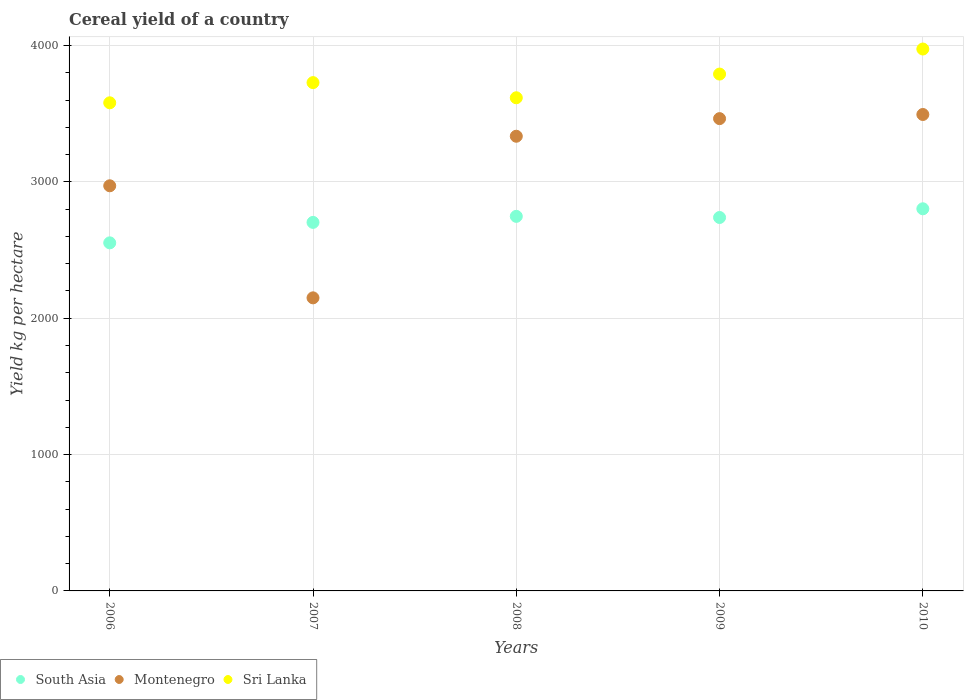Is the number of dotlines equal to the number of legend labels?
Your answer should be compact. Yes. What is the total cereal yield in South Asia in 2006?
Offer a very short reply. 2552.72. Across all years, what is the maximum total cereal yield in Sri Lanka?
Offer a very short reply. 3974.3. Across all years, what is the minimum total cereal yield in South Asia?
Ensure brevity in your answer.  2552.72. In which year was the total cereal yield in Montenegro minimum?
Your answer should be very brief. 2007. What is the total total cereal yield in Montenegro in the graph?
Keep it short and to the point. 1.54e+04. What is the difference between the total cereal yield in Montenegro in 2006 and that in 2009?
Provide a short and direct response. -492.53. What is the difference between the total cereal yield in Montenegro in 2009 and the total cereal yield in Sri Lanka in 2008?
Your answer should be compact. -152.98. What is the average total cereal yield in Montenegro per year?
Give a very brief answer. 3082.61. In the year 2008, what is the difference between the total cereal yield in Sri Lanka and total cereal yield in Montenegro?
Provide a short and direct response. 282.13. In how many years, is the total cereal yield in Sri Lanka greater than 3600 kg per hectare?
Offer a very short reply. 4. What is the ratio of the total cereal yield in Sri Lanka in 2006 to that in 2009?
Offer a terse response. 0.94. Is the difference between the total cereal yield in Sri Lanka in 2006 and 2009 greater than the difference between the total cereal yield in Montenegro in 2006 and 2009?
Your answer should be very brief. Yes. What is the difference between the highest and the second highest total cereal yield in Sri Lanka?
Give a very brief answer. 183.73. What is the difference between the highest and the lowest total cereal yield in South Asia?
Keep it short and to the point. 249.84. In how many years, is the total cereal yield in Montenegro greater than the average total cereal yield in Montenegro taken over all years?
Give a very brief answer. 3. Is it the case that in every year, the sum of the total cereal yield in Sri Lanka and total cereal yield in South Asia  is greater than the total cereal yield in Montenegro?
Offer a terse response. Yes. Is the total cereal yield in Montenegro strictly greater than the total cereal yield in Sri Lanka over the years?
Provide a short and direct response. No. Is the total cereal yield in South Asia strictly less than the total cereal yield in Montenegro over the years?
Give a very brief answer. No. How many years are there in the graph?
Make the answer very short. 5. Are the values on the major ticks of Y-axis written in scientific E-notation?
Offer a very short reply. No. Does the graph contain any zero values?
Ensure brevity in your answer.  No. Does the graph contain grids?
Offer a terse response. Yes. What is the title of the graph?
Ensure brevity in your answer.  Cereal yield of a country. Does "Tajikistan" appear as one of the legend labels in the graph?
Your answer should be very brief. No. What is the label or title of the X-axis?
Your response must be concise. Years. What is the label or title of the Y-axis?
Make the answer very short. Yield kg per hectare. What is the Yield kg per hectare in South Asia in 2006?
Offer a very short reply. 2552.72. What is the Yield kg per hectare of Montenegro in 2006?
Give a very brief answer. 2971.22. What is the Yield kg per hectare in Sri Lanka in 2006?
Your response must be concise. 3579.81. What is the Yield kg per hectare of South Asia in 2007?
Make the answer very short. 2702.79. What is the Yield kg per hectare in Montenegro in 2007?
Make the answer very short. 2149.37. What is the Yield kg per hectare of Sri Lanka in 2007?
Offer a terse response. 3727.89. What is the Yield kg per hectare of South Asia in 2008?
Ensure brevity in your answer.  2747.04. What is the Yield kg per hectare in Montenegro in 2008?
Your response must be concise. 3334.6. What is the Yield kg per hectare of Sri Lanka in 2008?
Provide a short and direct response. 3616.73. What is the Yield kg per hectare of South Asia in 2009?
Offer a terse response. 2738.72. What is the Yield kg per hectare in Montenegro in 2009?
Provide a succinct answer. 3463.75. What is the Yield kg per hectare of Sri Lanka in 2009?
Provide a short and direct response. 3790.57. What is the Yield kg per hectare of South Asia in 2010?
Your answer should be very brief. 2802.56. What is the Yield kg per hectare in Montenegro in 2010?
Provide a succinct answer. 3494.09. What is the Yield kg per hectare in Sri Lanka in 2010?
Provide a succinct answer. 3974.3. Across all years, what is the maximum Yield kg per hectare of South Asia?
Your response must be concise. 2802.56. Across all years, what is the maximum Yield kg per hectare of Montenegro?
Make the answer very short. 3494.09. Across all years, what is the maximum Yield kg per hectare of Sri Lanka?
Ensure brevity in your answer.  3974.3. Across all years, what is the minimum Yield kg per hectare in South Asia?
Make the answer very short. 2552.72. Across all years, what is the minimum Yield kg per hectare in Montenegro?
Your response must be concise. 2149.37. Across all years, what is the minimum Yield kg per hectare in Sri Lanka?
Keep it short and to the point. 3579.81. What is the total Yield kg per hectare in South Asia in the graph?
Your answer should be compact. 1.35e+04. What is the total Yield kg per hectare of Montenegro in the graph?
Ensure brevity in your answer.  1.54e+04. What is the total Yield kg per hectare of Sri Lanka in the graph?
Provide a succinct answer. 1.87e+04. What is the difference between the Yield kg per hectare in South Asia in 2006 and that in 2007?
Provide a short and direct response. -150.08. What is the difference between the Yield kg per hectare in Montenegro in 2006 and that in 2007?
Offer a terse response. 821.85. What is the difference between the Yield kg per hectare of Sri Lanka in 2006 and that in 2007?
Make the answer very short. -148.09. What is the difference between the Yield kg per hectare in South Asia in 2006 and that in 2008?
Offer a very short reply. -194.33. What is the difference between the Yield kg per hectare in Montenegro in 2006 and that in 2008?
Your response must be concise. -363.38. What is the difference between the Yield kg per hectare in Sri Lanka in 2006 and that in 2008?
Your answer should be compact. -36.92. What is the difference between the Yield kg per hectare of South Asia in 2006 and that in 2009?
Make the answer very short. -186.01. What is the difference between the Yield kg per hectare of Montenegro in 2006 and that in 2009?
Your answer should be compact. -492.52. What is the difference between the Yield kg per hectare of Sri Lanka in 2006 and that in 2009?
Give a very brief answer. -210.76. What is the difference between the Yield kg per hectare of South Asia in 2006 and that in 2010?
Offer a very short reply. -249.84. What is the difference between the Yield kg per hectare of Montenegro in 2006 and that in 2010?
Offer a terse response. -522.87. What is the difference between the Yield kg per hectare in Sri Lanka in 2006 and that in 2010?
Your answer should be very brief. -394.5. What is the difference between the Yield kg per hectare in South Asia in 2007 and that in 2008?
Keep it short and to the point. -44.25. What is the difference between the Yield kg per hectare of Montenegro in 2007 and that in 2008?
Keep it short and to the point. -1185.23. What is the difference between the Yield kg per hectare in Sri Lanka in 2007 and that in 2008?
Ensure brevity in your answer.  111.16. What is the difference between the Yield kg per hectare of South Asia in 2007 and that in 2009?
Keep it short and to the point. -35.93. What is the difference between the Yield kg per hectare of Montenegro in 2007 and that in 2009?
Ensure brevity in your answer.  -1314.38. What is the difference between the Yield kg per hectare of Sri Lanka in 2007 and that in 2009?
Offer a very short reply. -62.68. What is the difference between the Yield kg per hectare in South Asia in 2007 and that in 2010?
Provide a succinct answer. -99.76. What is the difference between the Yield kg per hectare in Montenegro in 2007 and that in 2010?
Your answer should be compact. -1344.72. What is the difference between the Yield kg per hectare of Sri Lanka in 2007 and that in 2010?
Offer a terse response. -246.41. What is the difference between the Yield kg per hectare in South Asia in 2008 and that in 2009?
Provide a short and direct response. 8.32. What is the difference between the Yield kg per hectare of Montenegro in 2008 and that in 2009?
Provide a short and direct response. -129.15. What is the difference between the Yield kg per hectare of Sri Lanka in 2008 and that in 2009?
Ensure brevity in your answer.  -173.84. What is the difference between the Yield kg per hectare in South Asia in 2008 and that in 2010?
Offer a very short reply. -55.52. What is the difference between the Yield kg per hectare of Montenegro in 2008 and that in 2010?
Make the answer very short. -159.49. What is the difference between the Yield kg per hectare of Sri Lanka in 2008 and that in 2010?
Offer a terse response. -357.57. What is the difference between the Yield kg per hectare of South Asia in 2009 and that in 2010?
Offer a very short reply. -63.83. What is the difference between the Yield kg per hectare in Montenegro in 2009 and that in 2010?
Offer a terse response. -30.34. What is the difference between the Yield kg per hectare of Sri Lanka in 2009 and that in 2010?
Ensure brevity in your answer.  -183.73. What is the difference between the Yield kg per hectare in South Asia in 2006 and the Yield kg per hectare in Montenegro in 2007?
Make the answer very short. 403.35. What is the difference between the Yield kg per hectare of South Asia in 2006 and the Yield kg per hectare of Sri Lanka in 2007?
Offer a very short reply. -1175.18. What is the difference between the Yield kg per hectare in Montenegro in 2006 and the Yield kg per hectare in Sri Lanka in 2007?
Your answer should be compact. -756.67. What is the difference between the Yield kg per hectare of South Asia in 2006 and the Yield kg per hectare of Montenegro in 2008?
Provide a short and direct response. -781.88. What is the difference between the Yield kg per hectare of South Asia in 2006 and the Yield kg per hectare of Sri Lanka in 2008?
Provide a succinct answer. -1064.01. What is the difference between the Yield kg per hectare in Montenegro in 2006 and the Yield kg per hectare in Sri Lanka in 2008?
Your response must be concise. -645.51. What is the difference between the Yield kg per hectare in South Asia in 2006 and the Yield kg per hectare in Montenegro in 2009?
Provide a short and direct response. -911.03. What is the difference between the Yield kg per hectare in South Asia in 2006 and the Yield kg per hectare in Sri Lanka in 2009?
Your response must be concise. -1237.86. What is the difference between the Yield kg per hectare in Montenegro in 2006 and the Yield kg per hectare in Sri Lanka in 2009?
Give a very brief answer. -819.35. What is the difference between the Yield kg per hectare of South Asia in 2006 and the Yield kg per hectare of Montenegro in 2010?
Provide a short and direct response. -941.37. What is the difference between the Yield kg per hectare in South Asia in 2006 and the Yield kg per hectare in Sri Lanka in 2010?
Offer a very short reply. -1421.59. What is the difference between the Yield kg per hectare of Montenegro in 2006 and the Yield kg per hectare of Sri Lanka in 2010?
Keep it short and to the point. -1003.08. What is the difference between the Yield kg per hectare in South Asia in 2007 and the Yield kg per hectare in Montenegro in 2008?
Your answer should be very brief. -631.8. What is the difference between the Yield kg per hectare in South Asia in 2007 and the Yield kg per hectare in Sri Lanka in 2008?
Make the answer very short. -913.94. What is the difference between the Yield kg per hectare of Montenegro in 2007 and the Yield kg per hectare of Sri Lanka in 2008?
Your response must be concise. -1467.36. What is the difference between the Yield kg per hectare in South Asia in 2007 and the Yield kg per hectare in Montenegro in 2009?
Your response must be concise. -760.95. What is the difference between the Yield kg per hectare of South Asia in 2007 and the Yield kg per hectare of Sri Lanka in 2009?
Give a very brief answer. -1087.78. What is the difference between the Yield kg per hectare in Montenegro in 2007 and the Yield kg per hectare in Sri Lanka in 2009?
Your answer should be very brief. -1641.2. What is the difference between the Yield kg per hectare of South Asia in 2007 and the Yield kg per hectare of Montenegro in 2010?
Offer a terse response. -791.3. What is the difference between the Yield kg per hectare in South Asia in 2007 and the Yield kg per hectare in Sri Lanka in 2010?
Make the answer very short. -1271.51. What is the difference between the Yield kg per hectare of Montenegro in 2007 and the Yield kg per hectare of Sri Lanka in 2010?
Offer a very short reply. -1824.93. What is the difference between the Yield kg per hectare of South Asia in 2008 and the Yield kg per hectare of Montenegro in 2009?
Offer a very short reply. -716.7. What is the difference between the Yield kg per hectare in South Asia in 2008 and the Yield kg per hectare in Sri Lanka in 2009?
Provide a succinct answer. -1043.53. What is the difference between the Yield kg per hectare of Montenegro in 2008 and the Yield kg per hectare of Sri Lanka in 2009?
Your response must be concise. -455.97. What is the difference between the Yield kg per hectare in South Asia in 2008 and the Yield kg per hectare in Montenegro in 2010?
Offer a very short reply. -747.05. What is the difference between the Yield kg per hectare in South Asia in 2008 and the Yield kg per hectare in Sri Lanka in 2010?
Your answer should be compact. -1227.26. What is the difference between the Yield kg per hectare of Montenegro in 2008 and the Yield kg per hectare of Sri Lanka in 2010?
Ensure brevity in your answer.  -639.71. What is the difference between the Yield kg per hectare of South Asia in 2009 and the Yield kg per hectare of Montenegro in 2010?
Keep it short and to the point. -755.37. What is the difference between the Yield kg per hectare in South Asia in 2009 and the Yield kg per hectare in Sri Lanka in 2010?
Provide a succinct answer. -1235.58. What is the difference between the Yield kg per hectare of Montenegro in 2009 and the Yield kg per hectare of Sri Lanka in 2010?
Ensure brevity in your answer.  -510.56. What is the average Yield kg per hectare of South Asia per year?
Provide a succinct answer. 2708.77. What is the average Yield kg per hectare of Montenegro per year?
Provide a short and direct response. 3082.61. What is the average Yield kg per hectare in Sri Lanka per year?
Offer a terse response. 3737.86. In the year 2006, what is the difference between the Yield kg per hectare in South Asia and Yield kg per hectare in Montenegro?
Ensure brevity in your answer.  -418.51. In the year 2006, what is the difference between the Yield kg per hectare of South Asia and Yield kg per hectare of Sri Lanka?
Provide a short and direct response. -1027.09. In the year 2006, what is the difference between the Yield kg per hectare of Montenegro and Yield kg per hectare of Sri Lanka?
Provide a succinct answer. -608.59. In the year 2007, what is the difference between the Yield kg per hectare in South Asia and Yield kg per hectare in Montenegro?
Your answer should be very brief. 553.42. In the year 2007, what is the difference between the Yield kg per hectare of South Asia and Yield kg per hectare of Sri Lanka?
Your answer should be very brief. -1025.1. In the year 2007, what is the difference between the Yield kg per hectare of Montenegro and Yield kg per hectare of Sri Lanka?
Keep it short and to the point. -1578.52. In the year 2008, what is the difference between the Yield kg per hectare in South Asia and Yield kg per hectare in Montenegro?
Ensure brevity in your answer.  -587.55. In the year 2008, what is the difference between the Yield kg per hectare in South Asia and Yield kg per hectare in Sri Lanka?
Offer a very short reply. -869.69. In the year 2008, what is the difference between the Yield kg per hectare of Montenegro and Yield kg per hectare of Sri Lanka?
Make the answer very short. -282.13. In the year 2009, what is the difference between the Yield kg per hectare of South Asia and Yield kg per hectare of Montenegro?
Provide a short and direct response. -725.02. In the year 2009, what is the difference between the Yield kg per hectare of South Asia and Yield kg per hectare of Sri Lanka?
Your response must be concise. -1051.85. In the year 2009, what is the difference between the Yield kg per hectare in Montenegro and Yield kg per hectare in Sri Lanka?
Provide a short and direct response. -326.82. In the year 2010, what is the difference between the Yield kg per hectare in South Asia and Yield kg per hectare in Montenegro?
Give a very brief answer. -691.53. In the year 2010, what is the difference between the Yield kg per hectare of South Asia and Yield kg per hectare of Sri Lanka?
Provide a short and direct response. -1171.74. In the year 2010, what is the difference between the Yield kg per hectare of Montenegro and Yield kg per hectare of Sri Lanka?
Provide a succinct answer. -480.21. What is the ratio of the Yield kg per hectare in South Asia in 2006 to that in 2007?
Offer a very short reply. 0.94. What is the ratio of the Yield kg per hectare in Montenegro in 2006 to that in 2007?
Your answer should be compact. 1.38. What is the ratio of the Yield kg per hectare in Sri Lanka in 2006 to that in 2007?
Make the answer very short. 0.96. What is the ratio of the Yield kg per hectare of South Asia in 2006 to that in 2008?
Offer a very short reply. 0.93. What is the ratio of the Yield kg per hectare of Montenegro in 2006 to that in 2008?
Provide a succinct answer. 0.89. What is the ratio of the Yield kg per hectare in South Asia in 2006 to that in 2009?
Provide a short and direct response. 0.93. What is the ratio of the Yield kg per hectare of Montenegro in 2006 to that in 2009?
Give a very brief answer. 0.86. What is the ratio of the Yield kg per hectare in Sri Lanka in 2006 to that in 2009?
Provide a succinct answer. 0.94. What is the ratio of the Yield kg per hectare in South Asia in 2006 to that in 2010?
Give a very brief answer. 0.91. What is the ratio of the Yield kg per hectare in Montenegro in 2006 to that in 2010?
Your answer should be compact. 0.85. What is the ratio of the Yield kg per hectare of Sri Lanka in 2006 to that in 2010?
Provide a succinct answer. 0.9. What is the ratio of the Yield kg per hectare of South Asia in 2007 to that in 2008?
Offer a terse response. 0.98. What is the ratio of the Yield kg per hectare of Montenegro in 2007 to that in 2008?
Offer a terse response. 0.64. What is the ratio of the Yield kg per hectare in Sri Lanka in 2007 to that in 2008?
Your answer should be compact. 1.03. What is the ratio of the Yield kg per hectare in South Asia in 2007 to that in 2009?
Offer a terse response. 0.99. What is the ratio of the Yield kg per hectare of Montenegro in 2007 to that in 2009?
Your answer should be very brief. 0.62. What is the ratio of the Yield kg per hectare in Sri Lanka in 2007 to that in 2009?
Ensure brevity in your answer.  0.98. What is the ratio of the Yield kg per hectare in South Asia in 2007 to that in 2010?
Offer a terse response. 0.96. What is the ratio of the Yield kg per hectare in Montenegro in 2007 to that in 2010?
Offer a terse response. 0.62. What is the ratio of the Yield kg per hectare in Sri Lanka in 2007 to that in 2010?
Keep it short and to the point. 0.94. What is the ratio of the Yield kg per hectare in Montenegro in 2008 to that in 2009?
Your response must be concise. 0.96. What is the ratio of the Yield kg per hectare of Sri Lanka in 2008 to that in 2009?
Provide a short and direct response. 0.95. What is the ratio of the Yield kg per hectare in South Asia in 2008 to that in 2010?
Give a very brief answer. 0.98. What is the ratio of the Yield kg per hectare of Montenegro in 2008 to that in 2010?
Keep it short and to the point. 0.95. What is the ratio of the Yield kg per hectare in Sri Lanka in 2008 to that in 2010?
Provide a succinct answer. 0.91. What is the ratio of the Yield kg per hectare in South Asia in 2009 to that in 2010?
Keep it short and to the point. 0.98. What is the ratio of the Yield kg per hectare in Sri Lanka in 2009 to that in 2010?
Give a very brief answer. 0.95. What is the difference between the highest and the second highest Yield kg per hectare of South Asia?
Keep it short and to the point. 55.52. What is the difference between the highest and the second highest Yield kg per hectare of Montenegro?
Offer a terse response. 30.34. What is the difference between the highest and the second highest Yield kg per hectare in Sri Lanka?
Ensure brevity in your answer.  183.73. What is the difference between the highest and the lowest Yield kg per hectare in South Asia?
Keep it short and to the point. 249.84. What is the difference between the highest and the lowest Yield kg per hectare in Montenegro?
Provide a short and direct response. 1344.72. What is the difference between the highest and the lowest Yield kg per hectare in Sri Lanka?
Your response must be concise. 394.5. 